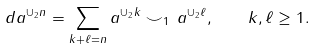<formula> <loc_0><loc_0><loc_500><loc_500>d a ^ { \cup _ { 2 } n } = \sum _ { k + \ell = n } a ^ { \cup _ { 2 } k } \smile _ { 1 } \, a ^ { \cup _ { 2 } \ell } , \quad k , \ell \geq 1 .</formula> 